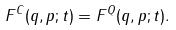Convert formula to latex. <formula><loc_0><loc_0><loc_500><loc_500>F ^ { C } ( q , p ; t ) = F ^ { Q } ( q , p ; t ) .</formula> 